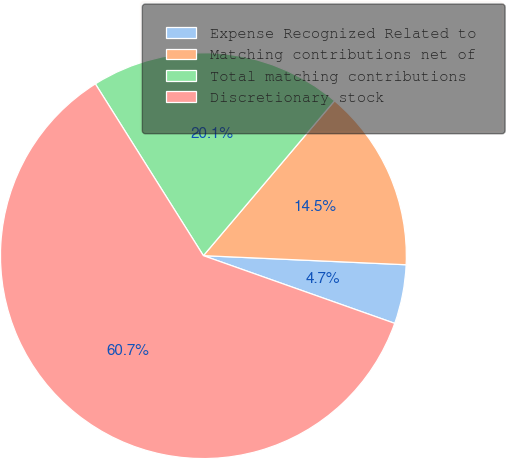Convert chart. <chart><loc_0><loc_0><loc_500><loc_500><pie_chart><fcel>Expense Recognized Related to<fcel>Matching contributions net of<fcel>Total matching contributions<fcel>Discretionary stock<nl><fcel>4.7%<fcel>14.53%<fcel>20.12%<fcel>60.65%<nl></chart> 